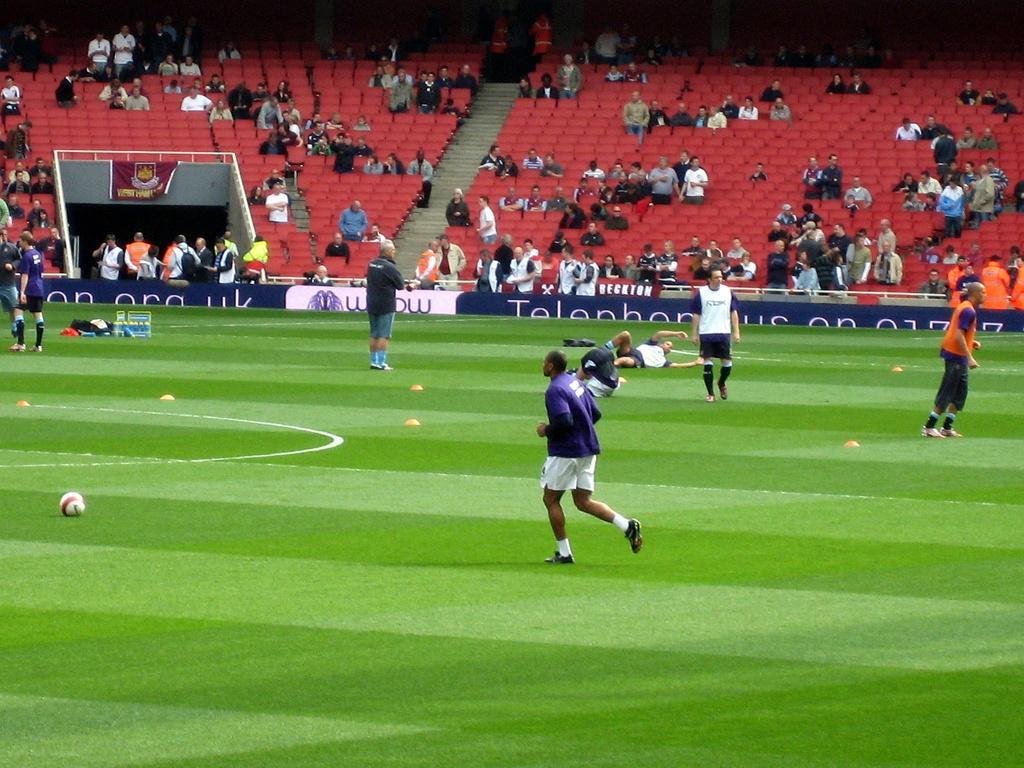How would you summarize this image in a sentence or two? Picture of a stadium. In this image we can see chairs, steps, people and hoarding. On grass there is a ball. Far there are things and banner. 